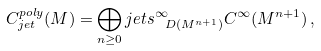Convert formula to latex. <formula><loc_0><loc_0><loc_500><loc_500>C _ { j e t } ^ { p o l y } ( M ) = \bigoplus _ { n \geq 0 } j e t s ^ { \infty } _ { \ D ( M ^ { n + 1 } ) } C ^ { \infty } ( M ^ { n + 1 } ) \, ,</formula> 